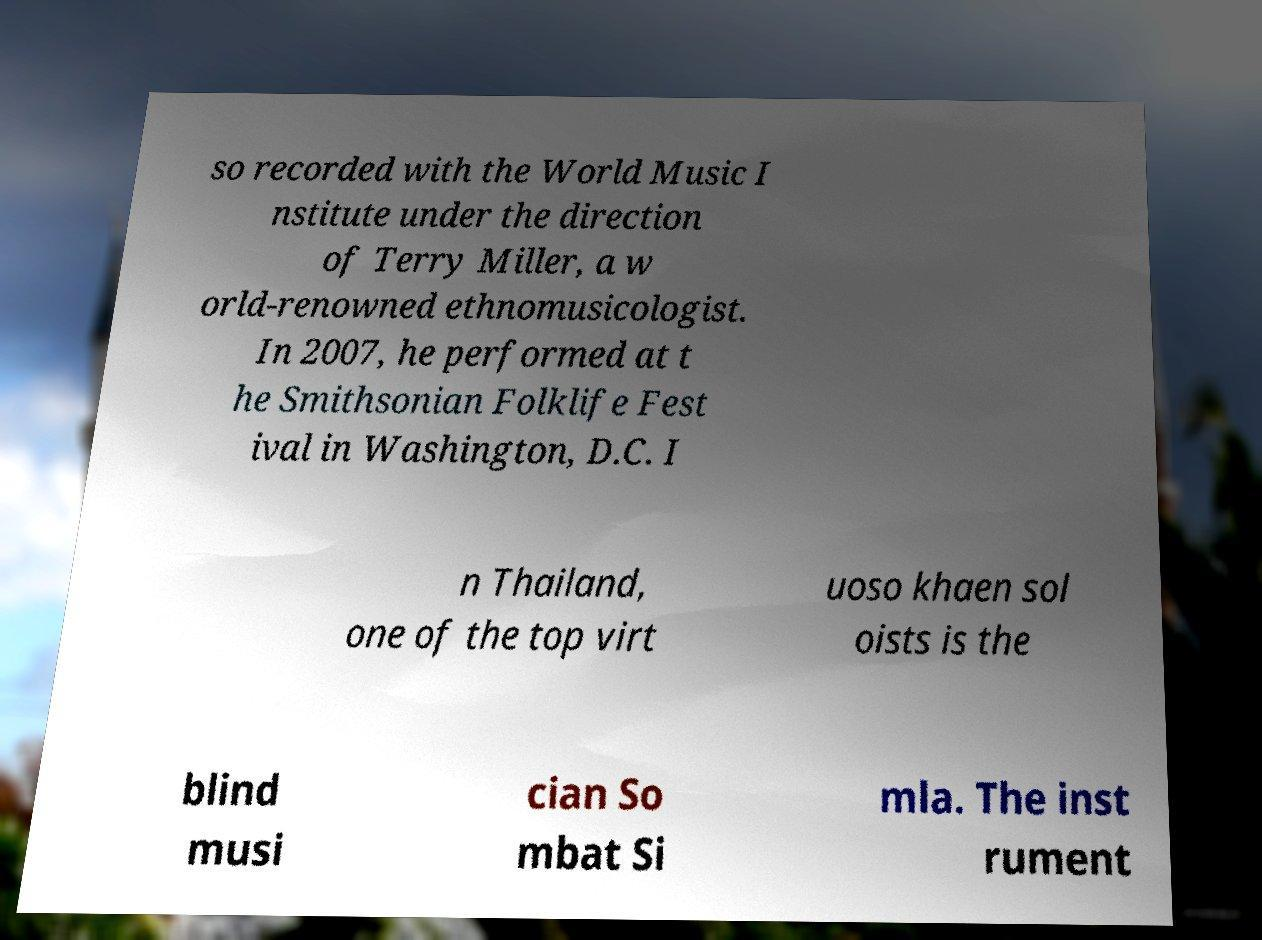Could you extract and type out the text from this image? so recorded with the World Music I nstitute under the direction of Terry Miller, a w orld-renowned ethnomusicologist. In 2007, he performed at t he Smithsonian Folklife Fest ival in Washington, D.C. I n Thailand, one of the top virt uoso khaen sol oists is the blind musi cian So mbat Si mla. The inst rument 